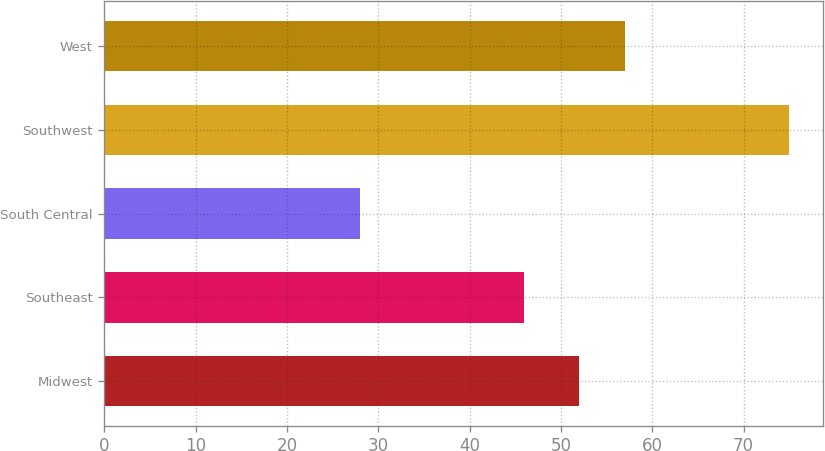Convert chart. <chart><loc_0><loc_0><loc_500><loc_500><bar_chart><fcel>Midwest<fcel>Southeast<fcel>South Central<fcel>Southwest<fcel>West<nl><fcel>52<fcel>46<fcel>28<fcel>75<fcel>57<nl></chart> 